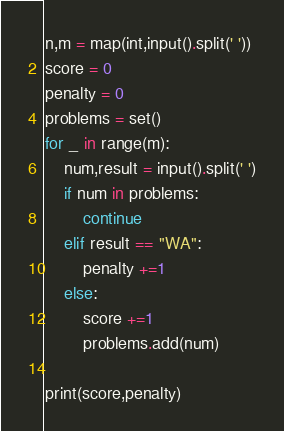<code> <loc_0><loc_0><loc_500><loc_500><_Python_>n,m = map(int,input().split(' '))
score = 0
penalty = 0
problems = set()
for _ in range(m):
    num,result = input().split(' ')
    if num in problems:
        continue
    elif result == "WA":
        penalty +=1
    else:
        score +=1
        problems.add(num)

print(score,penalty)</code> 